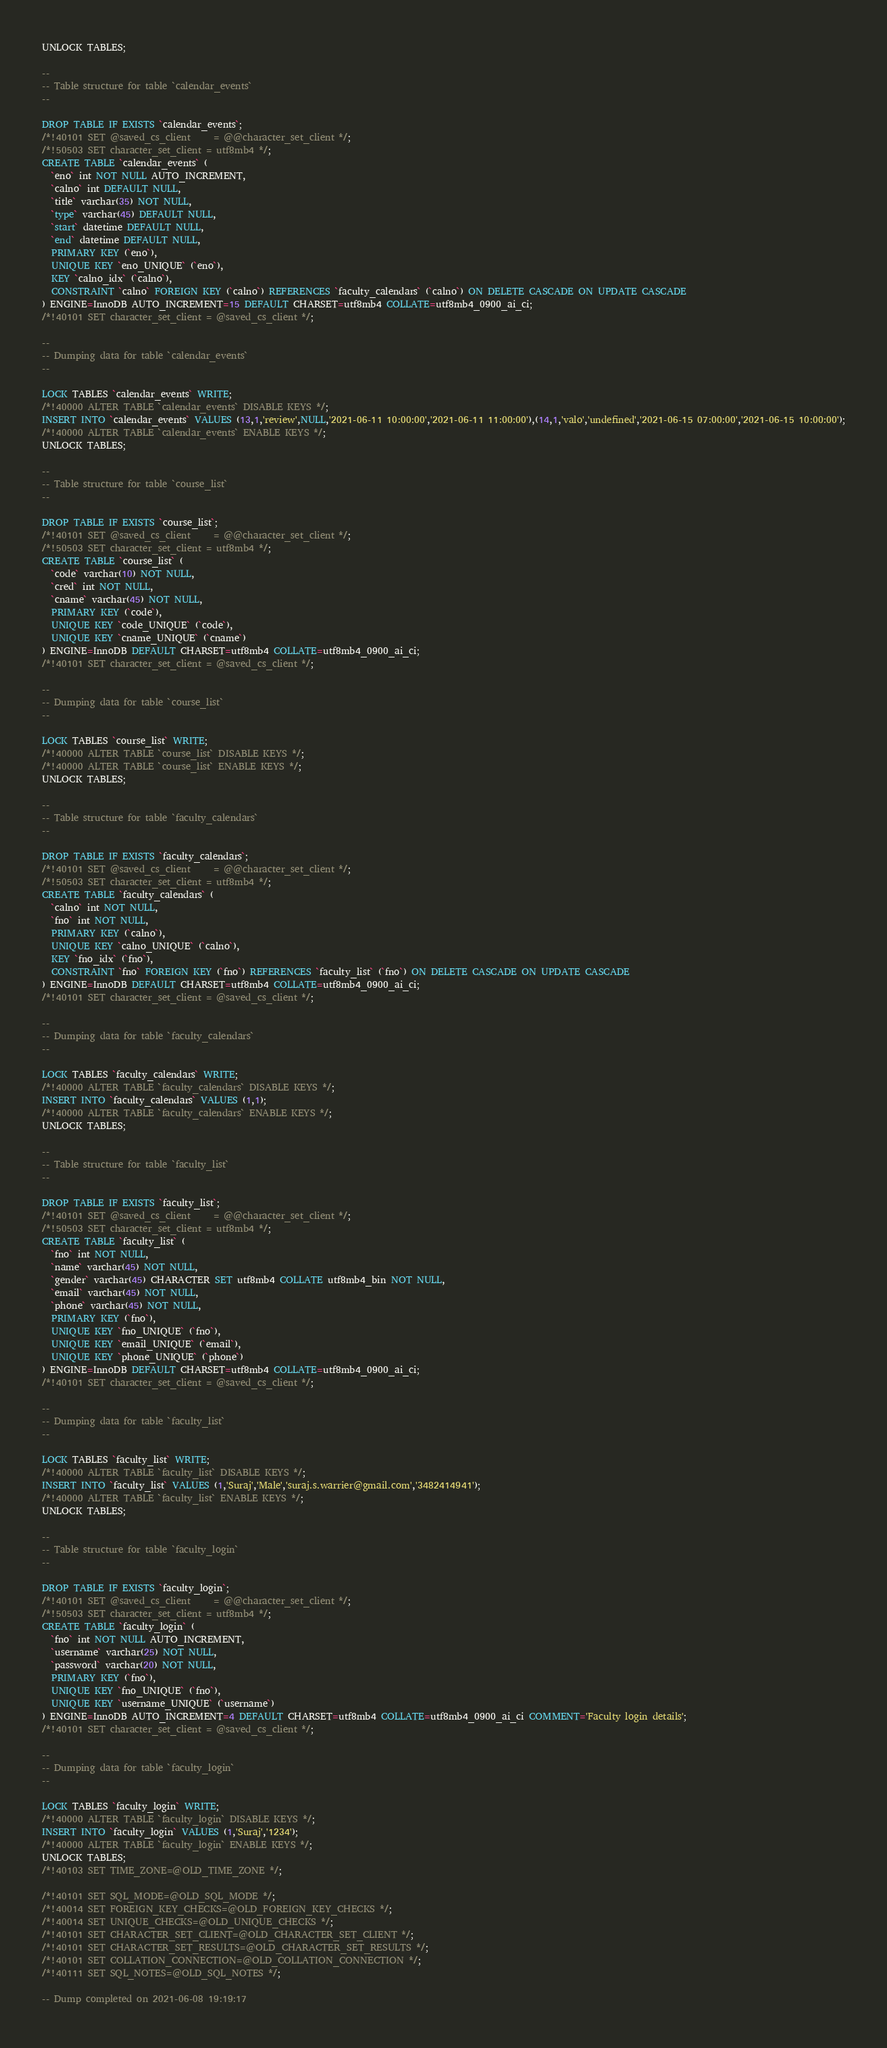Convert code to text. <code><loc_0><loc_0><loc_500><loc_500><_SQL_>UNLOCK TABLES;

--
-- Table structure for table `calendar_events`
--

DROP TABLE IF EXISTS `calendar_events`;
/*!40101 SET @saved_cs_client     = @@character_set_client */;
/*!50503 SET character_set_client = utf8mb4 */;
CREATE TABLE `calendar_events` (
  `eno` int NOT NULL AUTO_INCREMENT,
  `calno` int DEFAULT NULL,
  `title` varchar(35) NOT NULL,
  `type` varchar(45) DEFAULT NULL,
  `start` datetime DEFAULT NULL,
  `end` datetime DEFAULT NULL,
  PRIMARY KEY (`eno`),
  UNIQUE KEY `eno_UNIQUE` (`eno`),
  KEY `calno_idx` (`calno`),
  CONSTRAINT `calno` FOREIGN KEY (`calno`) REFERENCES `faculty_calendars` (`calno`) ON DELETE CASCADE ON UPDATE CASCADE
) ENGINE=InnoDB AUTO_INCREMENT=15 DEFAULT CHARSET=utf8mb4 COLLATE=utf8mb4_0900_ai_ci;
/*!40101 SET character_set_client = @saved_cs_client */;

--
-- Dumping data for table `calendar_events`
--

LOCK TABLES `calendar_events` WRITE;
/*!40000 ALTER TABLE `calendar_events` DISABLE KEYS */;
INSERT INTO `calendar_events` VALUES (13,1,'review',NULL,'2021-06-11 10:00:00','2021-06-11 11:00:00'),(14,1,'valo','undefined','2021-06-15 07:00:00','2021-06-15 10:00:00');
/*!40000 ALTER TABLE `calendar_events` ENABLE KEYS */;
UNLOCK TABLES;

--
-- Table structure for table `course_list`
--

DROP TABLE IF EXISTS `course_list`;
/*!40101 SET @saved_cs_client     = @@character_set_client */;
/*!50503 SET character_set_client = utf8mb4 */;
CREATE TABLE `course_list` (
  `code` varchar(10) NOT NULL,
  `cred` int NOT NULL,
  `cname` varchar(45) NOT NULL,
  PRIMARY KEY (`code`),
  UNIQUE KEY `code_UNIQUE` (`code`),
  UNIQUE KEY `cname_UNIQUE` (`cname`)
) ENGINE=InnoDB DEFAULT CHARSET=utf8mb4 COLLATE=utf8mb4_0900_ai_ci;
/*!40101 SET character_set_client = @saved_cs_client */;

--
-- Dumping data for table `course_list`
--

LOCK TABLES `course_list` WRITE;
/*!40000 ALTER TABLE `course_list` DISABLE KEYS */;
/*!40000 ALTER TABLE `course_list` ENABLE KEYS */;
UNLOCK TABLES;

--
-- Table structure for table `faculty_calendars`
--

DROP TABLE IF EXISTS `faculty_calendars`;
/*!40101 SET @saved_cs_client     = @@character_set_client */;
/*!50503 SET character_set_client = utf8mb4 */;
CREATE TABLE `faculty_calendars` (
  `calno` int NOT NULL,
  `fno` int NOT NULL,
  PRIMARY KEY (`calno`),
  UNIQUE KEY `calno_UNIQUE` (`calno`),
  KEY `fno_idx` (`fno`),
  CONSTRAINT `fno` FOREIGN KEY (`fno`) REFERENCES `faculty_list` (`fno`) ON DELETE CASCADE ON UPDATE CASCADE
) ENGINE=InnoDB DEFAULT CHARSET=utf8mb4 COLLATE=utf8mb4_0900_ai_ci;
/*!40101 SET character_set_client = @saved_cs_client */;

--
-- Dumping data for table `faculty_calendars`
--

LOCK TABLES `faculty_calendars` WRITE;
/*!40000 ALTER TABLE `faculty_calendars` DISABLE KEYS */;
INSERT INTO `faculty_calendars` VALUES (1,1);
/*!40000 ALTER TABLE `faculty_calendars` ENABLE KEYS */;
UNLOCK TABLES;

--
-- Table structure for table `faculty_list`
--

DROP TABLE IF EXISTS `faculty_list`;
/*!40101 SET @saved_cs_client     = @@character_set_client */;
/*!50503 SET character_set_client = utf8mb4 */;
CREATE TABLE `faculty_list` (
  `fno` int NOT NULL,
  `name` varchar(45) NOT NULL,
  `gender` varchar(45) CHARACTER SET utf8mb4 COLLATE utf8mb4_bin NOT NULL,
  `email` varchar(45) NOT NULL,
  `phone` varchar(45) NOT NULL,
  PRIMARY KEY (`fno`),
  UNIQUE KEY `fno_UNIQUE` (`fno`),
  UNIQUE KEY `email_UNIQUE` (`email`),
  UNIQUE KEY `phone_UNIQUE` (`phone`)
) ENGINE=InnoDB DEFAULT CHARSET=utf8mb4 COLLATE=utf8mb4_0900_ai_ci;
/*!40101 SET character_set_client = @saved_cs_client */;

--
-- Dumping data for table `faculty_list`
--

LOCK TABLES `faculty_list` WRITE;
/*!40000 ALTER TABLE `faculty_list` DISABLE KEYS */;
INSERT INTO `faculty_list` VALUES (1,'Suraj','Male','suraj.s.warrier@gmail.com','3482414941');
/*!40000 ALTER TABLE `faculty_list` ENABLE KEYS */;
UNLOCK TABLES;

--
-- Table structure for table `faculty_login`
--

DROP TABLE IF EXISTS `faculty_login`;
/*!40101 SET @saved_cs_client     = @@character_set_client */;
/*!50503 SET character_set_client = utf8mb4 */;
CREATE TABLE `faculty_login` (
  `fno` int NOT NULL AUTO_INCREMENT,
  `username` varchar(25) NOT NULL,
  `password` varchar(20) NOT NULL,
  PRIMARY KEY (`fno`),
  UNIQUE KEY `fno_UNIQUE` (`fno`),
  UNIQUE KEY `username_UNIQUE` (`username`)
) ENGINE=InnoDB AUTO_INCREMENT=4 DEFAULT CHARSET=utf8mb4 COLLATE=utf8mb4_0900_ai_ci COMMENT='Faculty login details';
/*!40101 SET character_set_client = @saved_cs_client */;

--
-- Dumping data for table `faculty_login`
--

LOCK TABLES `faculty_login` WRITE;
/*!40000 ALTER TABLE `faculty_login` DISABLE KEYS */;
INSERT INTO `faculty_login` VALUES (1,'Suraj','1234');
/*!40000 ALTER TABLE `faculty_login` ENABLE KEYS */;
UNLOCK TABLES;
/*!40103 SET TIME_ZONE=@OLD_TIME_ZONE */;

/*!40101 SET SQL_MODE=@OLD_SQL_MODE */;
/*!40014 SET FOREIGN_KEY_CHECKS=@OLD_FOREIGN_KEY_CHECKS */;
/*!40014 SET UNIQUE_CHECKS=@OLD_UNIQUE_CHECKS */;
/*!40101 SET CHARACTER_SET_CLIENT=@OLD_CHARACTER_SET_CLIENT */;
/*!40101 SET CHARACTER_SET_RESULTS=@OLD_CHARACTER_SET_RESULTS */;
/*!40101 SET COLLATION_CONNECTION=@OLD_COLLATION_CONNECTION */;
/*!40111 SET SQL_NOTES=@OLD_SQL_NOTES */;

-- Dump completed on 2021-06-08 19:19:17
</code> 